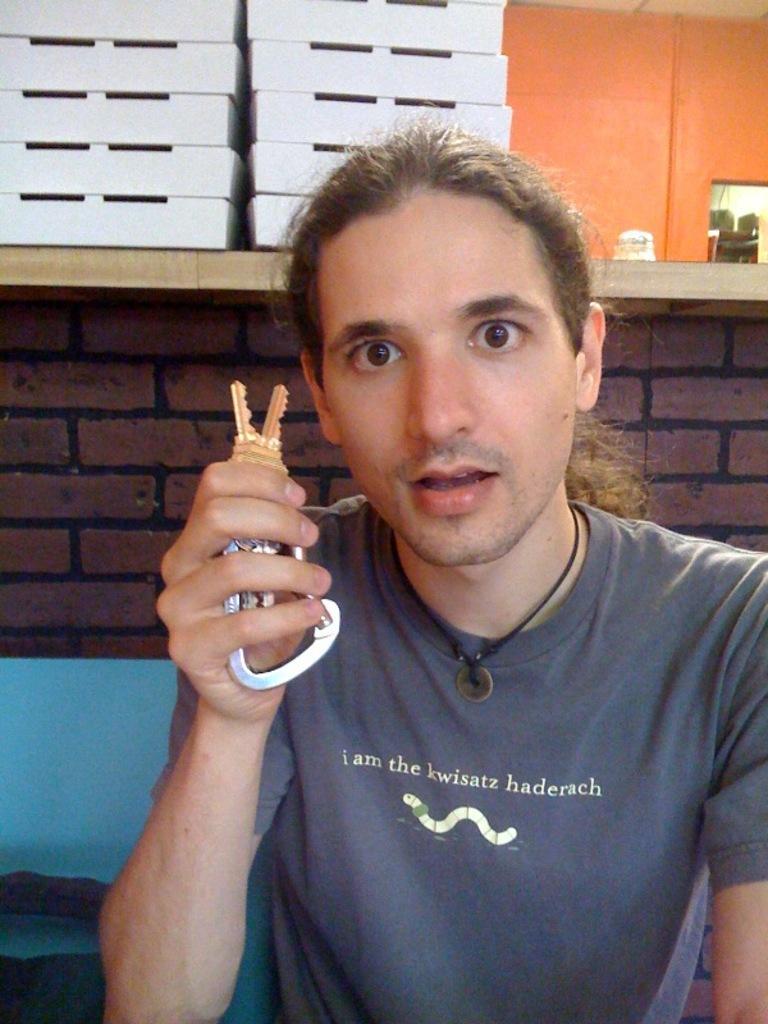Can you describe this image briefly? In this image I can see a person holding a key in the background I can see the wall and the bench and top of bench I can see white color baskets. 